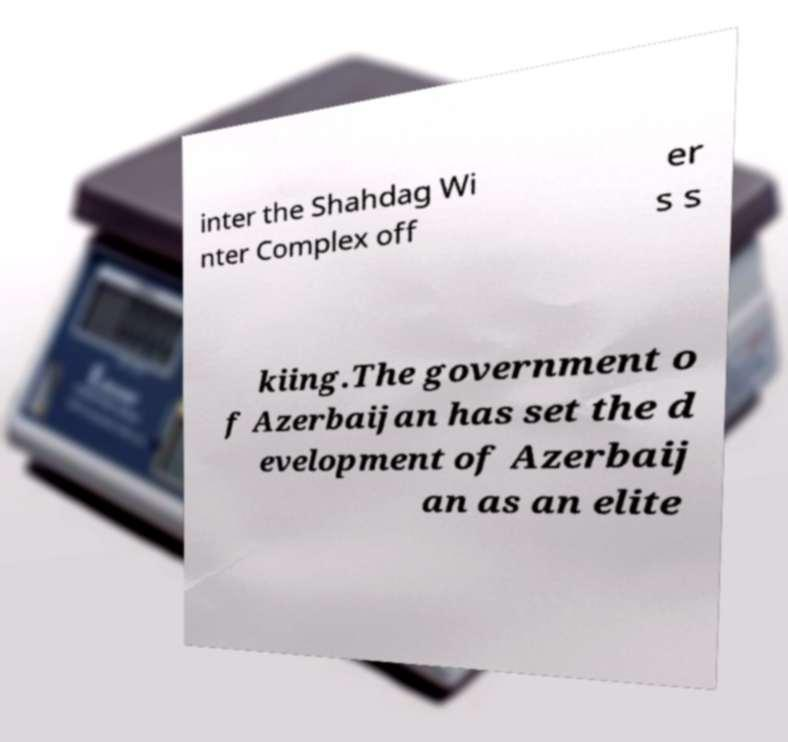Please read and relay the text visible in this image. What does it say? inter the Shahdag Wi nter Complex off er s s kiing.The government o f Azerbaijan has set the d evelopment of Azerbaij an as an elite 